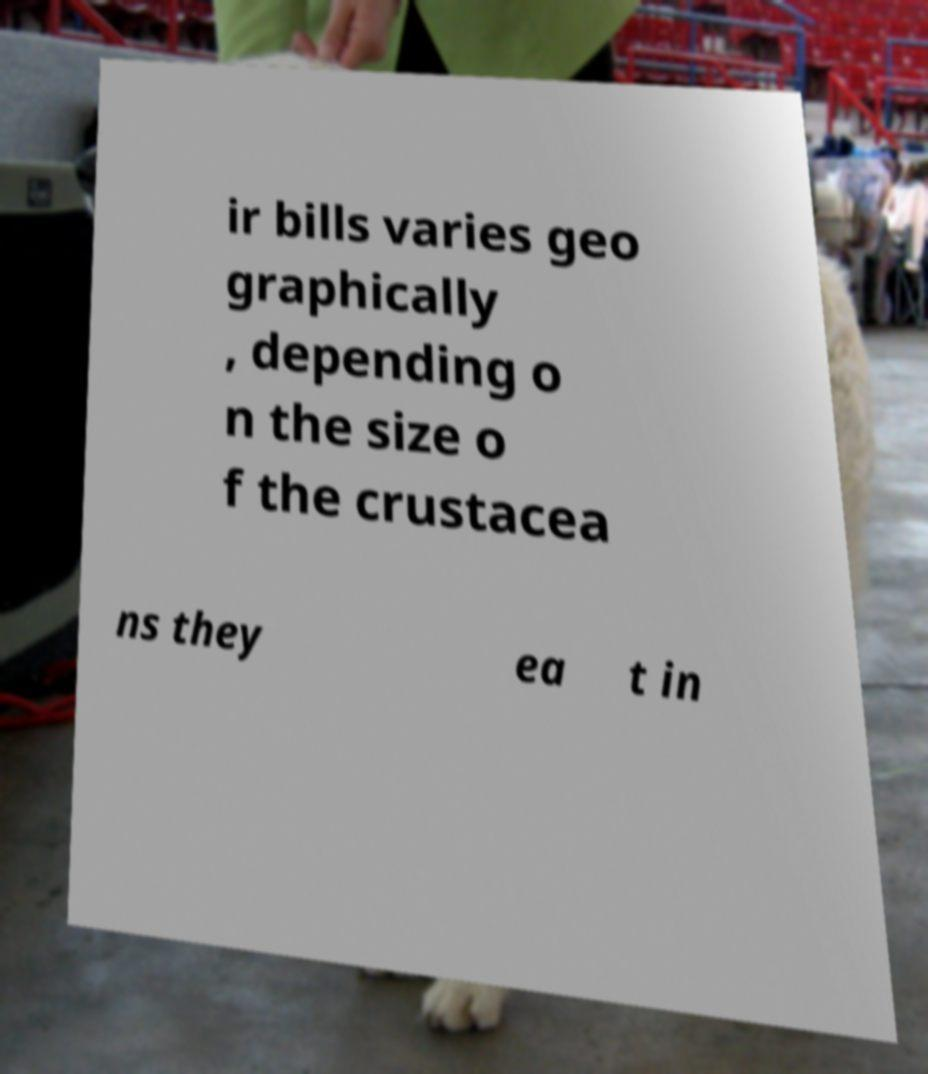Could you extract and type out the text from this image? ir bills varies geo graphically , depending o n the size o f the crustacea ns they ea t in 